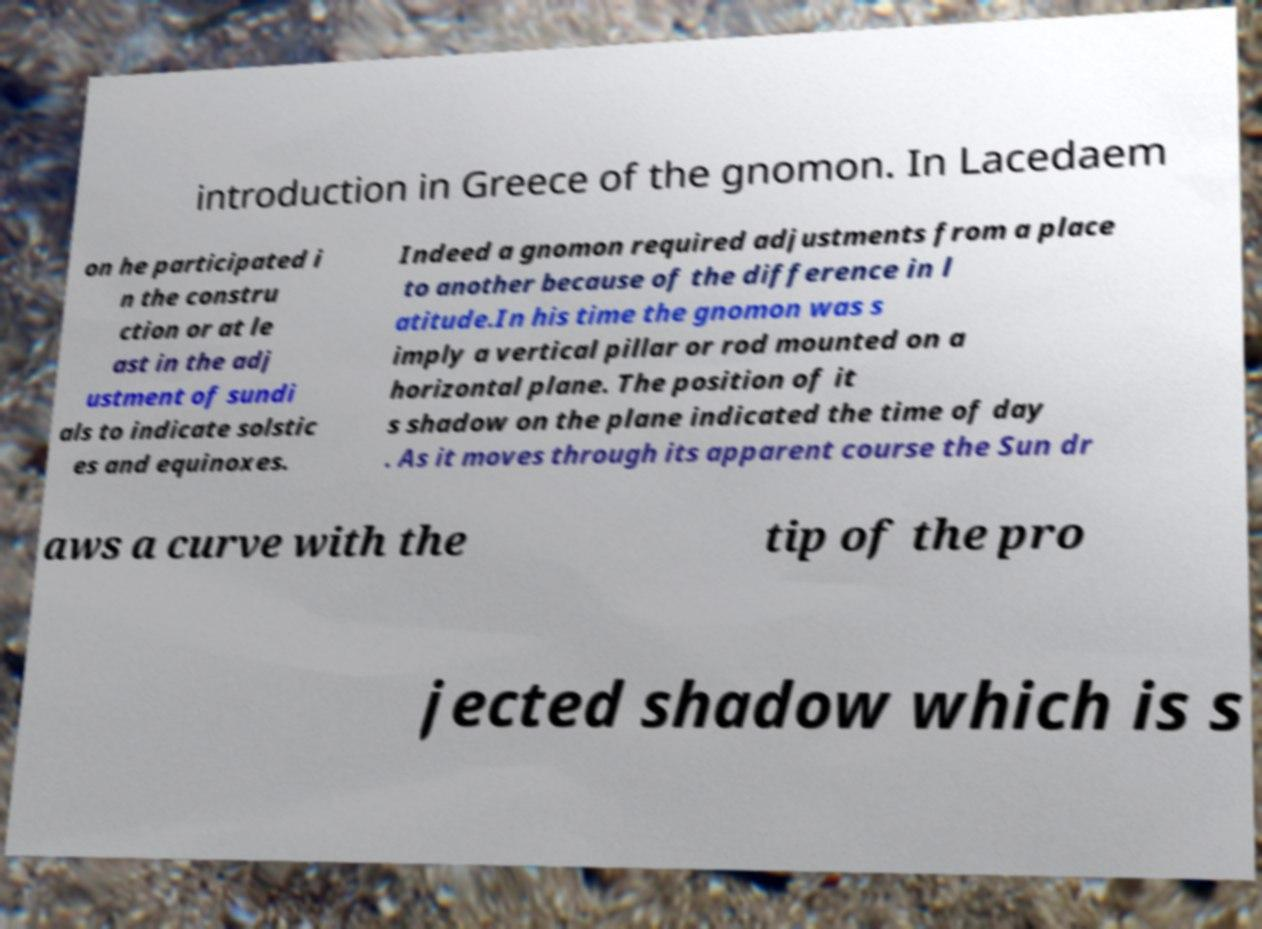Can you read and provide the text displayed in the image?This photo seems to have some interesting text. Can you extract and type it out for me? introduction in Greece of the gnomon. In Lacedaem on he participated i n the constru ction or at le ast in the adj ustment of sundi als to indicate solstic es and equinoxes. Indeed a gnomon required adjustments from a place to another because of the difference in l atitude.In his time the gnomon was s imply a vertical pillar or rod mounted on a horizontal plane. The position of it s shadow on the plane indicated the time of day . As it moves through its apparent course the Sun dr aws a curve with the tip of the pro jected shadow which is s 